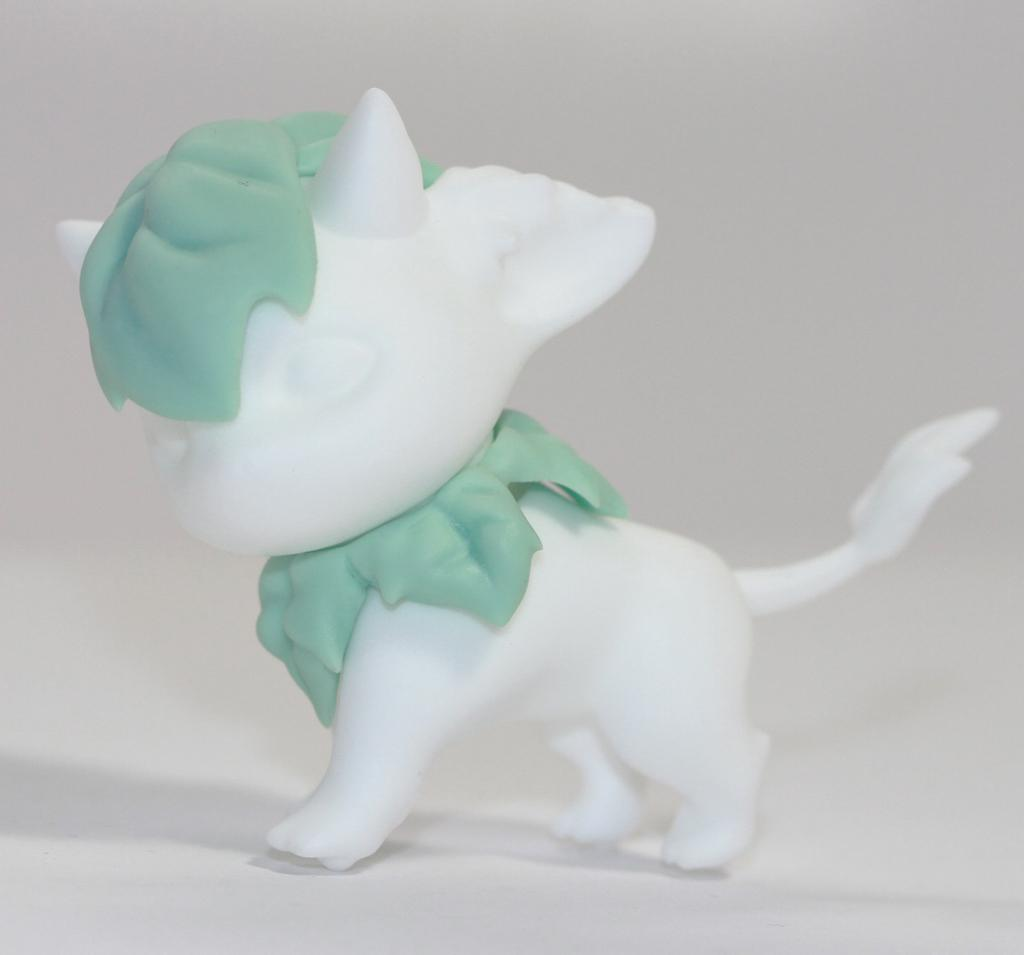What object can be seen in the image? There is a toy in the image. Where is the toy located? The toy is on a surface. What color is the background of the image? The background of the image is white. What type of canvas is visible in the image? There is no canvas present in the image. Can you see any cemetery in the image? There is no cemetery present in the image. 